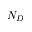Convert formula to latex. <formula><loc_0><loc_0><loc_500><loc_500>N _ { D }</formula> 